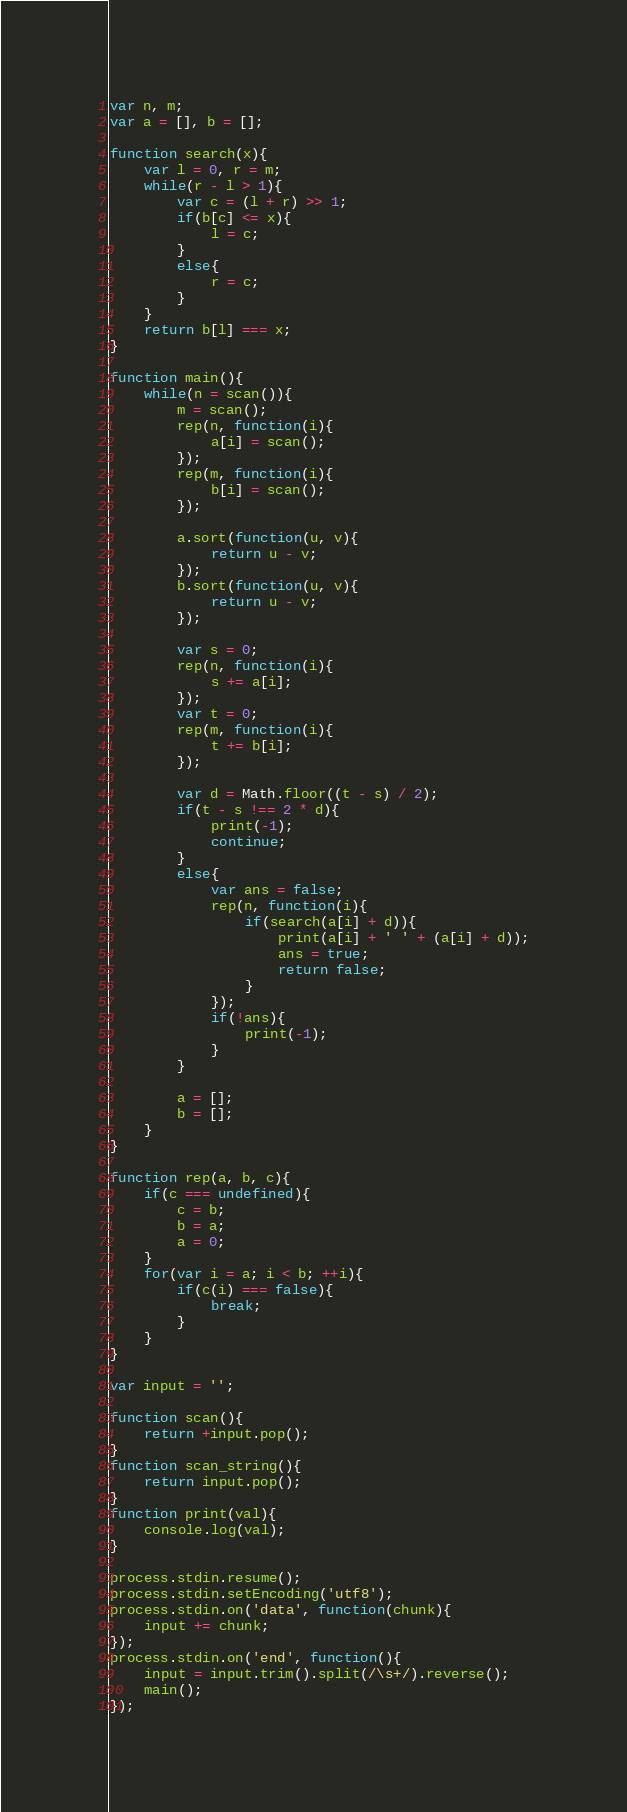<code> <loc_0><loc_0><loc_500><loc_500><_JavaScript_>var n, m;
var a = [], b = [];

function search(x){
	var l = 0, r = m;
	while(r - l > 1){
		var c = (l + r) >> 1;
		if(b[c] <= x){
			l = c;
		}
		else{
			r = c;
		}
	}
	return b[l] === x;
}

function main(){
	while(n = scan()){
		m = scan();
		rep(n, function(i){
			a[i] = scan();
		});
		rep(m, function(i){
			b[i] = scan();
		});

		a.sort(function(u, v){
			return u - v;
		});
		b.sort(function(u, v){
			return u - v;
		});

		var s = 0;
		rep(n, function(i){
			s += a[i];
		});
		var t = 0;
		rep(m, function(i){
			t += b[i];
		});

		var d = Math.floor((t - s) / 2);
		if(t - s !== 2 * d){
			print(-1);
			continue;
		}
		else{
			var ans = false;
			rep(n, function(i){
				if(search(a[i] + d)){
					print(a[i] + ' ' + (a[i] + d));
					ans = true;
					return false;
				}
			});
			if(!ans){
				print(-1);
			}
		}

		a = [];
		b = [];
	}
}

function rep(a, b, c){
	if(c === undefined){
		c = b;
		b = a;
		a = 0;
	}
	for(var i = a; i < b; ++i){
		if(c(i) === false){
			break;
		}
	}
}

var input = '';

function scan(){
	return +input.pop();
}
function scan_string(){
	return input.pop();
} 
function print(val){
	console.log(val);
}
 
process.stdin.resume();
process.stdin.setEncoding('utf8');
process.stdin.on('data', function(chunk){
	input += chunk;
});
process.stdin.on('end', function(){
	input = input.trim().split(/\s+/).reverse();
	main();
});</code> 